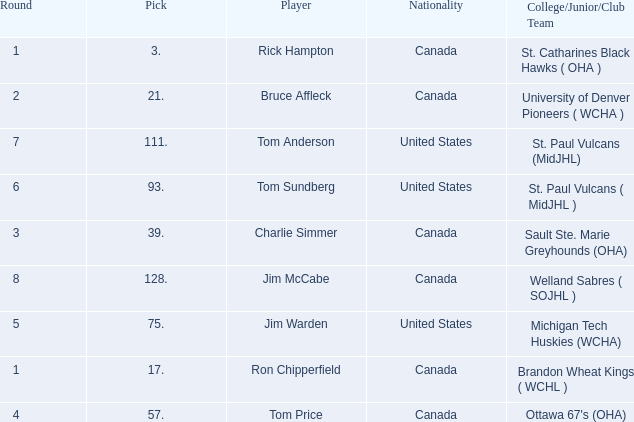Can you tell me the College/Junior/Club Team that has the Round of 4? Ottawa 67's (OHA). 